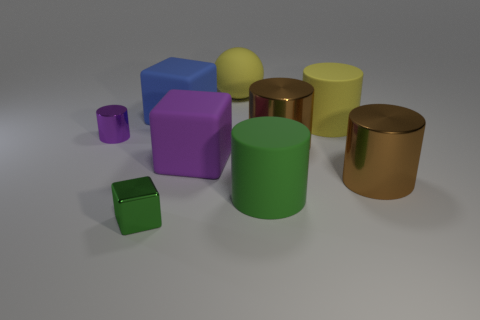Are there any patterns or textures on the objects? No, the objects in the image don't display any distinct patterns or textures. All of them have a solid color with a finish that varies from matte to metallic, giving an impression of different materials. 